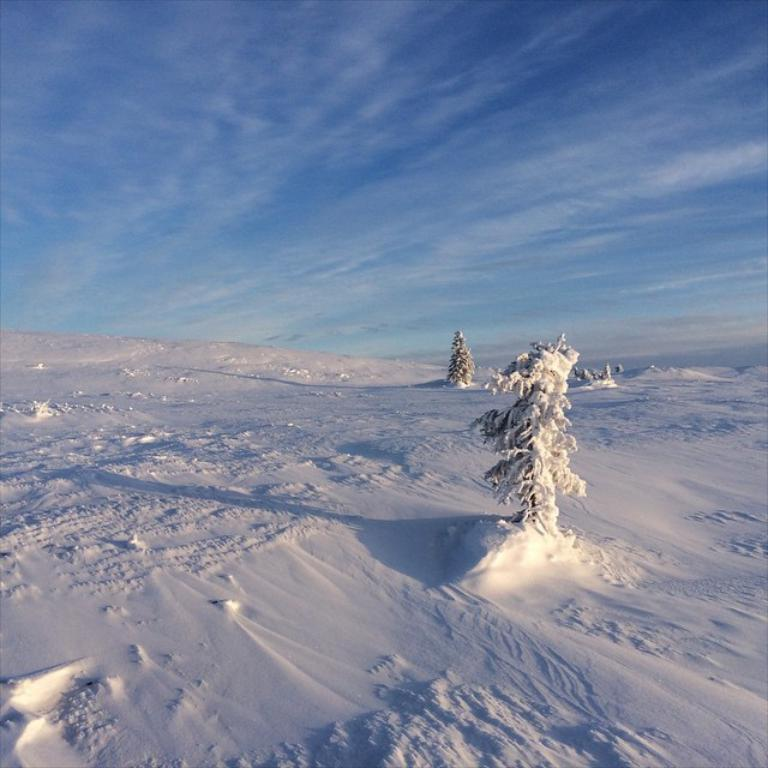What is the condition of the land in the image? The land in the image is covered with snow. What else is covered with snow in the image? The trees in the image are also covered with snow. What can be seen in the sky in the image? The sky is visible in the image, and it looks cloudy. What type of good-bye is being said in the image? There is no indication of anyone saying good-bye in the image. What is the air quality like in the image? The provided facts do not give any information about the air quality in the image. 